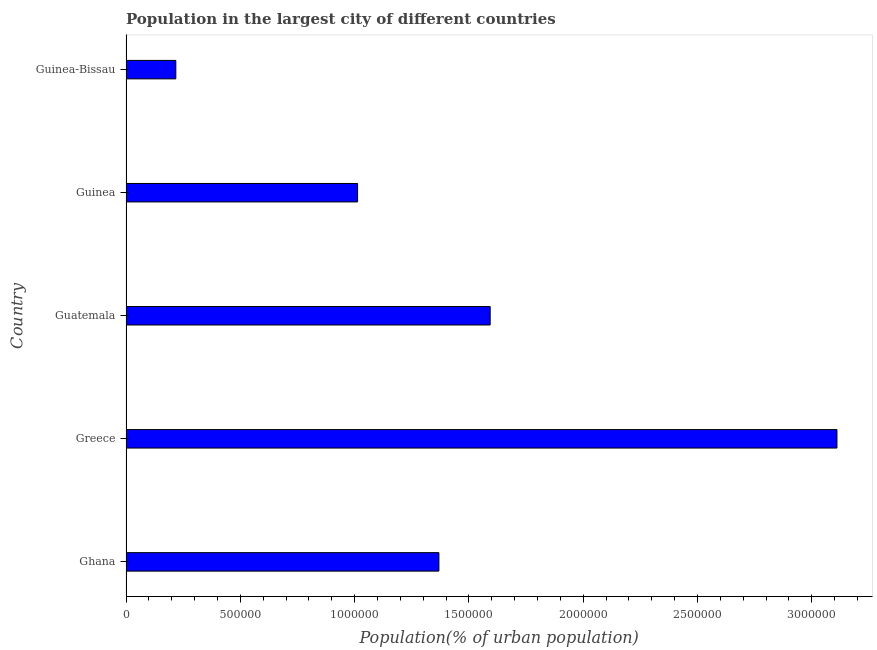Does the graph contain any zero values?
Make the answer very short. No. Does the graph contain grids?
Offer a terse response. No. What is the title of the graph?
Provide a short and direct response. Population in the largest city of different countries. What is the label or title of the X-axis?
Offer a terse response. Population(% of urban population). What is the population in largest city in Greece?
Keep it short and to the point. 3.11e+06. Across all countries, what is the maximum population in largest city?
Ensure brevity in your answer.  3.11e+06. Across all countries, what is the minimum population in largest city?
Offer a very short reply. 2.18e+05. In which country was the population in largest city minimum?
Offer a very short reply. Guinea-Bissau. What is the sum of the population in largest city?
Keep it short and to the point. 7.30e+06. What is the difference between the population in largest city in Ghana and Greece?
Give a very brief answer. -1.74e+06. What is the average population in largest city per country?
Your answer should be very brief. 1.46e+06. What is the median population in largest city?
Give a very brief answer. 1.37e+06. What is the ratio of the population in largest city in Guinea to that in Guinea-Bissau?
Ensure brevity in your answer.  4.65. Is the difference between the population in largest city in Guatemala and Guinea-Bissau greater than the difference between any two countries?
Offer a very short reply. No. What is the difference between the highest and the second highest population in largest city?
Your answer should be compact. 1.52e+06. What is the difference between the highest and the lowest population in largest city?
Provide a succinct answer. 2.89e+06. How many bars are there?
Your answer should be very brief. 5. Are all the bars in the graph horizontal?
Ensure brevity in your answer.  Yes. How many countries are there in the graph?
Make the answer very short. 5. Are the values on the major ticks of X-axis written in scientific E-notation?
Keep it short and to the point. No. What is the Population(% of urban population) in Ghana?
Provide a succinct answer. 1.37e+06. What is the Population(% of urban population) in Greece?
Give a very brief answer. 3.11e+06. What is the Population(% of urban population) in Guatemala?
Offer a terse response. 1.59e+06. What is the Population(% of urban population) of Guinea?
Provide a short and direct response. 1.01e+06. What is the Population(% of urban population) of Guinea-Bissau?
Offer a terse response. 2.18e+05. What is the difference between the Population(% of urban population) in Ghana and Greece?
Ensure brevity in your answer.  -1.74e+06. What is the difference between the Population(% of urban population) in Ghana and Guatemala?
Your answer should be compact. -2.24e+05. What is the difference between the Population(% of urban population) in Ghana and Guinea?
Your response must be concise. 3.56e+05. What is the difference between the Population(% of urban population) in Ghana and Guinea-Bissau?
Your answer should be very brief. 1.15e+06. What is the difference between the Population(% of urban population) in Greece and Guatemala?
Offer a terse response. 1.52e+06. What is the difference between the Population(% of urban population) in Greece and Guinea?
Ensure brevity in your answer.  2.10e+06. What is the difference between the Population(% of urban population) in Greece and Guinea-Bissau?
Provide a short and direct response. 2.89e+06. What is the difference between the Population(% of urban population) in Guatemala and Guinea?
Your answer should be very brief. 5.80e+05. What is the difference between the Population(% of urban population) in Guatemala and Guinea-Bissau?
Ensure brevity in your answer.  1.38e+06. What is the difference between the Population(% of urban population) in Guinea and Guinea-Bissau?
Your answer should be compact. 7.95e+05. What is the ratio of the Population(% of urban population) in Ghana to that in Greece?
Offer a very short reply. 0.44. What is the ratio of the Population(% of urban population) in Ghana to that in Guatemala?
Make the answer very short. 0.86. What is the ratio of the Population(% of urban population) in Ghana to that in Guinea?
Your answer should be compact. 1.35. What is the ratio of the Population(% of urban population) in Ghana to that in Guinea-Bissau?
Offer a terse response. 6.28. What is the ratio of the Population(% of urban population) in Greece to that in Guatemala?
Provide a short and direct response. 1.95. What is the ratio of the Population(% of urban population) in Greece to that in Guinea?
Ensure brevity in your answer.  3.07. What is the ratio of the Population(% of urban population) in Greece to that in Guinea-Bissau?
Ensure brevity in your answer.  14.27. What is the ratio of the Population(% of urban population) in Guatemala to that in Guinea?
Ensure brevity in your answer.  1.57. What is the ratio of the Population(% of urban population) in Guatemala to that in Guinea-Bissau?
Keep it short and to the point. 7.31. What is the ratio of the Population(% of urban population) in Guinea to that in Guinea-Bissau?
Your answer should be very brief. 4.65. 